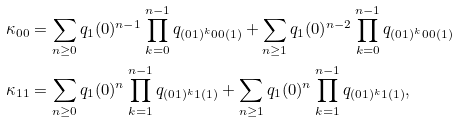<formula> <loc_0><loc_0><loc_500><loc_500>\kappa _ { 0 0 } & = \sum _ { n \geq 0 } q _ { 1 } ( 0 ) ^ { n - 1 } \prod _ { k = 0 } ^ { n - 1 } q _ { ( 0 1 ) ^ { k } 0 0 ( 1 ) } + \sum _ { n \geq 1 } q _ { 1 } ( 0 ) ^ { n - 2 } \prod _ { k = 0 } ^ { n - 1 } q _ { ( 0 1 ) ^ { k } 0 0 ( 1 ) } \\ \kappa _ { 1 1 } & = \sum _ { n \geq 0 } q _ { 1 } ( 0 ) ^ { n } \prod _ { k = 1 } ^ { n - 1 } q _ { ( 0 1 ) ^ { k } 1 ( 1 ) } + \sum _ { n \geq 1 } q _ { 1 } ( 0 ) ^ { n } \prod _ { k = 1 } ^ { n - 1 } q _ { ( 0 1 ) ^ { k } 1 ( 1 ) } ,</formula> 